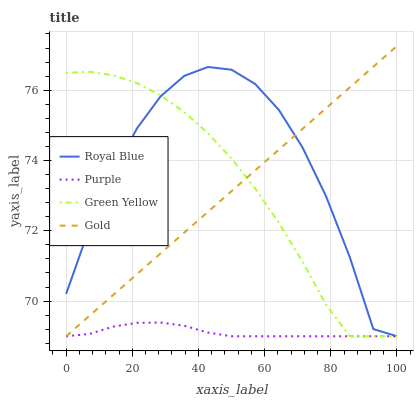Does Green Yellow have the minimum area under the curve?
Answer yes or no. No. Does Green Yellow have the maximum area under the curve?
Answer yes or no. No. Is Green Yellow the smoothest?
Answer yes or no. No. Is Green Yellow the roughest?
Answer yes or no. No. Does Royal Blue have the highest value?
Answer yes or no. No. 